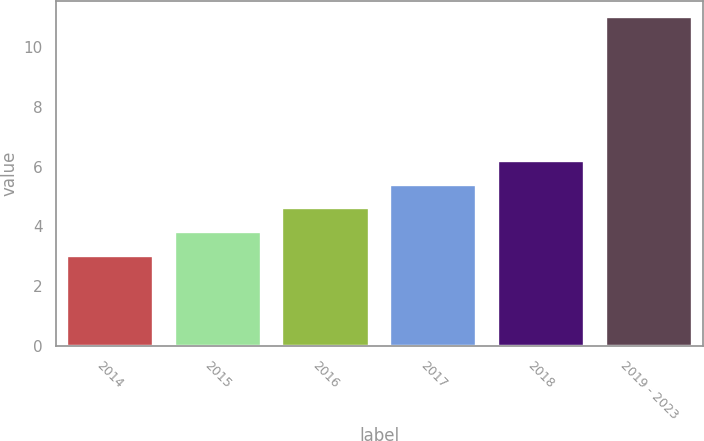Convert chart. <chart><loc_0><loc_0><loc_500><loc_500><bar_chart><fcel>2014<fcel>2015<fcel>2016<fcel>2017<fcel>2018<fcel>2019 - 2023<nl><fcel>3<fcel>3.8<fcel>4.6<fcel>5.4<fcel>6.2<fcel>11<nl></chart> 